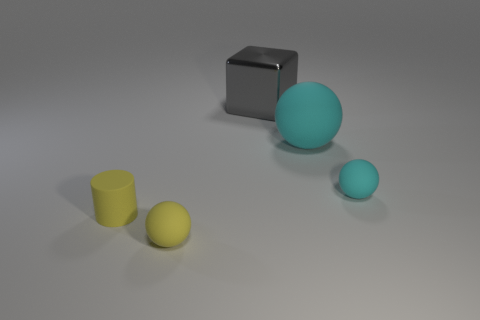What number of other things are there of the same color as the cylinder?
Provide a short and direct response. 1. There is a rubber thing in front of the yellow matte cylinder; is its size the same as the metallic object that is right of the yellow cylinder?
Keep it short and to the point. No. Does the yellow cylinder have the same material as the cyan thing in front of the big cyan rubber ball?
Offer a terse response. Yes. Is the number of cubes that are in front of the small yellow matte ball greater than the number of tiny balls to the left of the big metallic thing?
Your answer should be compact. No. The rubber sphere behind the tiny object that is behind the rubber cylinder is what color?
Provide a succinct answer. Cyan. How many cylinders are small yellow objects or big rubber things?
Your answer should be very brief. 1. What number of spheres are both in front of the big matte object and to the right of the large gray shiny thing?
Ensure brevity in your answer.  1. The tiny sphere that is on the left side of the metal object is what color?
Your answer should be very brief. Yellow. There is a cyan object that is the same material as the tiny cyan ball; what is its size?
Make the answer very short. Large. There is a tiny sphere to the left of the tiny cyan matte sphere; what number of big rubber balls are to the right of it?
Your response must be concise. 1. 